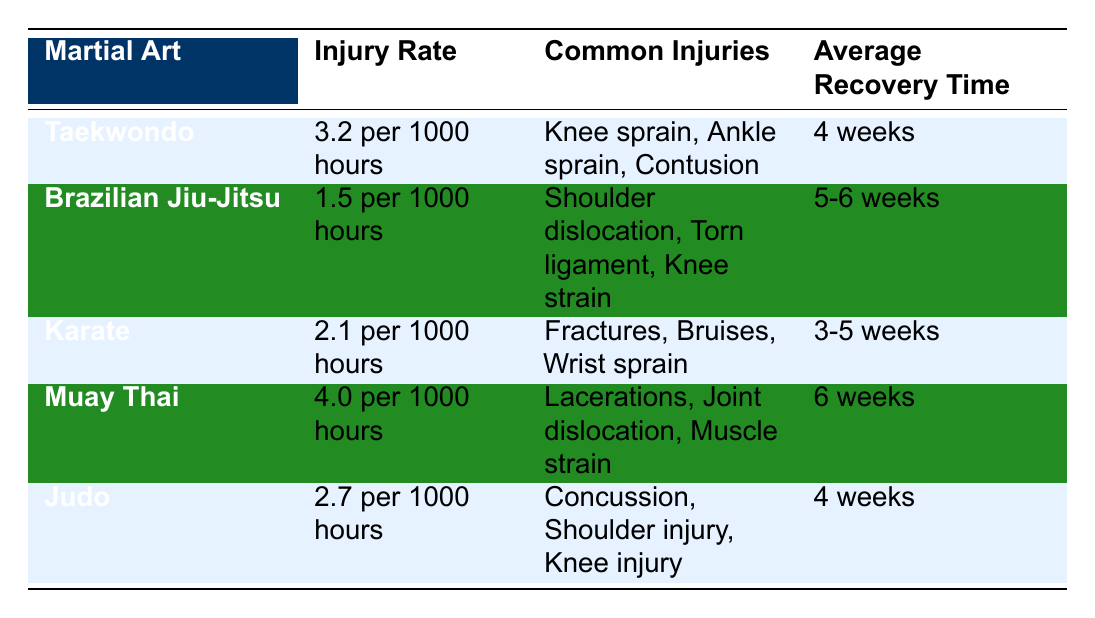Which martial art has the highest injury rate? The data shows injury rates for each martial art. Comparing them, Muay Thai has an injury rate of 4.0 injuries per 1000 hours, which is higher than all other listed martial arts.
Answer: Muay Thai What is the average recovery time for Karate? The table lists Karate's average recovery time as 3-5 weeks.
Answer: 3-5 weeks Does Brazilian Jiu-Jitsu have a lower injury rate than Judo? Brazilian Jiu-Jitsu has an injury rate of 1.5 injuries per 1000 hours, while Judo has a higher rate of 2.7 injuries per 1000 hours. Hence, the statement is true.
Answer: Yes Which common injury is associated with Taekwondo? The table indicates that common injuries associated with Taekwondo include Knee sprain, Ankle sprain, and Contusion.
Answer: Knee sprain, Ankle sprain, Contusion What is the average recovery time across all martial arts? The average recovery times for the martial arts are: Taekwondo (4 weeks), Brazilian Jiu-Jitsu (5.5 weeks average), Karate (4 weeks average), Muay Thai (6 weeks), and Judo (4 weeks). To find the overall average, we can sum these times and divide by the total number of martial arts: (4 + 5.5 + 4 + 6 + 4) / 5 = 23.5 / 5 = 4.7 weeks.
Answer: 4.7 weeks Is it true that the average recovery time for Muay Thai is longer than that of Taekwondo? Muay Thai has an average recovery time of 6 weeks, while Taekwondo has 4 weeks, which confirms that it is true.
Answer: Yes Which martial art has the shortest recovery time? In the table, Karate has the shortest average recovery time listed as 3-5 weeks, which is less than the others.
Answer: Karate How many common injuries are listed for Brazilian Jiu-Jitsu? Brazilian Jiu-Jitsu has three common injuries listed: Shoulder dislocation, Torn ligament, and Knee strain.
Answer: Three injuries Which martial art has a recovery time of exactly 6 weeks? The table specifies that Muay Thai has an average recovery time of exactly 6 weeks.
Answer: Muay Thai 